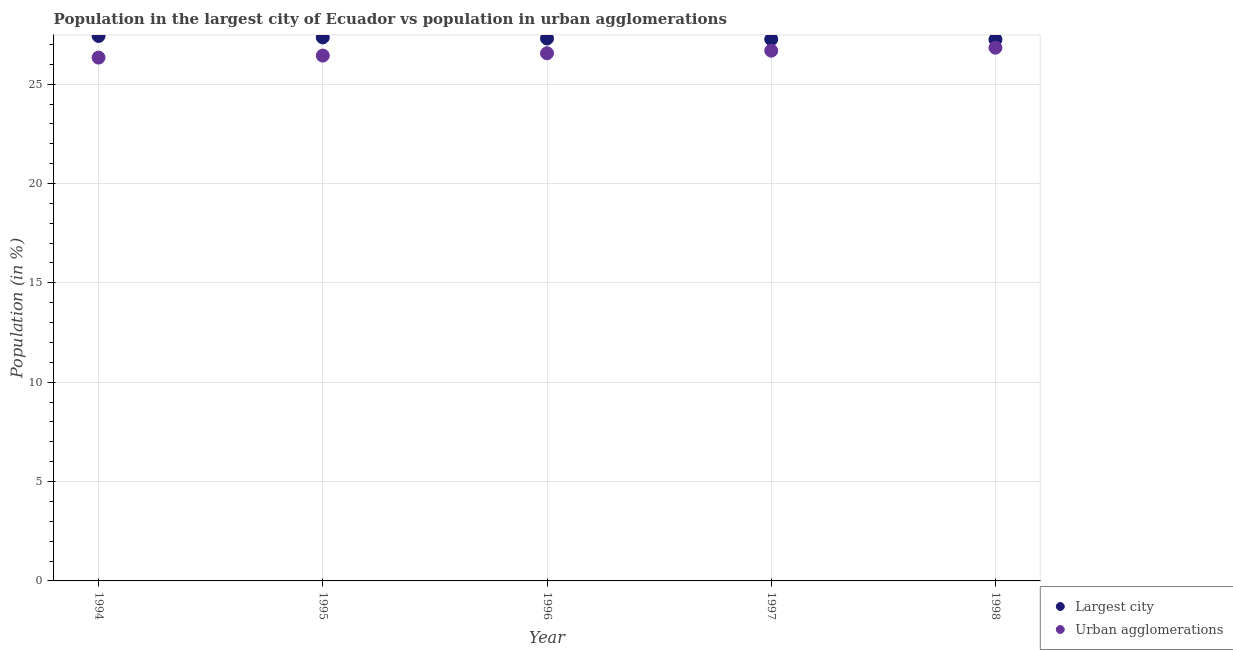What is the population in urban agglomerations in 1996?
Ensure brevity in your answer.  26.56. Across all years, what is the maximum population in the largest city?
Your response must be concise. 27.43. Across all years, what is the minimum population in urban agglomerations?
Your answer should be very brief. 26.34. In which year was the population in the largest city minimum?
Ensure brevity in your answer.  1998. What is the total population in the largest city in the graph?
Your answer should be compact. 136.58. What is the difference between the population in urban agglomerations in 1994 and that in 1997?
Keep it short and to the point. -0.35. What is the difference between the population in the largest city in 1997 and the population in urban agglomerations in 1994?
Ensure brevity in your answer.  0.92. What is the average population in urban agglomerations per year?
Give a very brief answer. 26.57. In the year 1998, what is the difference between the population in urban agglomerations and population in the largest city?
Ensure brevity in your answer.  -0.41. What is the ratio of the population in urban agglomerations in 1995 to that in 1997?
Offer a terse response. 0.99. What is the difference between the highest and the second highest population in urban agglomerations?
Offer a very short reply. 0.15. What is the difference between the highest and the lowest population in urban agglomerations?
Give a very brief answer. 0.5. Is the sum of the population in the largest city in 1994 and 1997 greater than the maximum population in urban agglomerations across all years?
Provide a short and direct response. Yes. Is the population in urban agglomerations strictly greater than the population in the largest city over the years?
Provide a short and direct response. No. How many years are there in the graph?
Your answer should be very brief. 5. Are the values on the major ticks of Y-axis written in scientific E-notation?
Offer a very short reply. No. Does the graph contain grids?
Keep it short and to the point. Yes. How are the legend labels stacked?
Your answer should be very brief. Vertical. What is the title of the graph?
Your answer should be compact. Population in the largest city of Ecuador vs population in urban agglomerations. Does "Technicians" appear as one of the legend labels in the graph?
Your response must be concise. No. What is the label or title of the X-axis?
Keep it short and to the point. Year. What is the label or title of the Y-axis?
Keep it short and to the point. Population (in %). What is the Population (in %) of Largest city in 1994?
Keep it short and to the point. 27.43. What is the Population (in %) of Urban agglomerations in 1994?
Ensure brevity in your answer.  26.34. What is the Population (in %) in Largest city in 1995?
Ensure brevity in your answer.  27.35. What is the Population (in %) of Urban agglomerations in 1995?
Offer a terse response. 26.44. What is the Population (in %) of Largest city in 1996?
Ensure brevity in your answer.  27.3. What is the Population (in %) of Urban agglomerations in 1996?
Your answer should be very brief. 26.56. What is the Population (in %) of Largest city in 1997?
Ensure brevity in your answer.  27.26. What is the Population (in %) of Urban agglomerations in 1997?
Your response must be concise. 26.69. What is the Population (in %) of Largest city in 1998?
Your response must be concise. 27.25. What is the Population (in %) in Urban agglomerations in 1998?
Ensure brevity in your answer.  26.84. Across all years, what is the maximum Population (in %) of Largest city?
Provide a short and direct response. 27.43. Across all years, what is the maximum Population (in %) of Urban agglomerations?
Give a very brief answer. 26.84. Across all years, what is the minimum Population (in %) of Largest city?
Offer a very short reply. 27.25. Across all years, what is the minimum Population (in %) of Urban agglomerations?
Provide a succinct answer. 26.34. What is the total Population (in %) in Largest city in the graph?
Ensure brevity in your answer.  136.58. What is the total Population (in %) of Urban agglomerations in the graph?
Give a very brief answer. 132.85. What is the difference between the Population (in %) in Largest city in 1994 and that in 1995?
Offer a very short reply. 0.07. What is the difference between the Population (in %) of Urban agglomerations in 1994 and that in 1995?
Your answer should be very brief. -0.1. What is the difference between the Population (in %) of Largest city in 1994 and that in 1996?
Make the answer very short. 0.13. What is the difference between the Population (in %) in Urban agglomerations in 1994 and that in 1996?
Your answer should be compact. -0.22. What is the difference between the Population (in %) of Largest city in 1994 and that in 1997?
Give a very brief answer. 0.16. What is the difference between the Population (in %) in Urban agglomerations in 1994 and that in 1997?
Your answer should be very brief. -0.35. What is the difference between the Population (in %) in Largest city in 1994 and that in 1998?
Ensure brevity in your answer.  0.18. What is the difference between the Population (in %) of Urban agglomerations in 1994 and that in 1998?
Your response must be concise. -0.5. What is the difference between the Population (in %) of Largest city in 1995 and that in 1996?
Make the answer very short. 0.05. What is the difference between the Population (in %) in Urban agglomerations in 1995 and that in 1996?
Offer a very short reply. -0.12. What is the difference between the Population (in %) of Largest city in 1995 and that in 1997?
Ensure brevity in your answer.  0.09. What is the difference between the Population (in %) of Urban agglomerations in 1995 and that in 1997?
Make the answer very short. -0.25. What is the difference between the Population (in %) of Largest city in 1995 and that in 1998?
Provide a short and direct response. 0.11. What is the difference between the Population (in %) in Urban agglomerations in 1995 and that in 1998?
Offer a terse response. -0.4. What is the difference between the Population (in %) of Largest city in 1996 and that in 1997?
Your answer should be very brief. 0.04. What is the difference between the Population (in %) in Urban agglomerations in 1996 and that in 1997?
Offer a terse response. -0.13. What is the difference between the Population (in %) of Largest city in 1996 and that in 1998?
Offer a very short reply. 0.05. What is the difference between the Population (in %) of Urban agglomerations in 1996 and that in 1998?
Your answer should be compact. -0.28. What is the difference between the Population (in %) of Largest city in 1997 and that in 1998?
Make the answer very short. 0.02. What is the difference between the Population (in %) in Urban agglomerations in 1997 and that in 1998?
Your answer should be very brief. -0.15. What is the difference between the Population (in %) in Largest city in 1994 and the Population (in %) in Urban agglomerations in 1995?
Your answer should be very brief. 0.99. What is the difference between the Population (in %) of Largest city in 1994 and the Population (in %) of Urban agglomerations in 1996?
Provide a short and direct response. 0.87. What is the difference between the Population (in %) in Largest city in 1994 and the Population (in %) in Urban agglomerations in 1997?
Offer a terse response. 0.74. What is the difference between the Population (in %) of Largest city in 1994 and the Population (in %) of Urban agglomerations in 1998?
Offer a terse response. 0.59. What is the difference between the Population (in %) of Largest city in 1995 and the Population (in %) of Urban agglomerations in 1996?
Your answer should be very brief. 0.8. What is the difference between the Population (in %) in Largest city in 1995 and the Population (in %) in Urban agglomerations in 1997?
Keep it short and to the point. 0.67. What is the difference between the Population (in %) of Largest city in 1995 and the Population (in %) of Urban agglomerations in 1998?
Offer a very short reply. 0.52. What is the difference between the Population (in %) of Largest city in 1996 and the Population (in %) of Urban agglomerations in 1997?
Offer a terse response. 0.61. What is the difference between the Population (in %) in Largest city in 1996 and the Population (in %) in Urban agglomerations in 1998?
Your response must be concise. 0.46. What is the difference between the Population (in %) in Largest city in 1997 and the Population (in %) in Urban agglomerations in 1998?
Ensure brevity in your answer.  0.43. What is the average Population (in %) in Largest city per year?
Provide a succinct answer. 27.32. What is the average Population (in %) of Urban agglomerations per year?
Offer a very short reply. 26.57. In the year 1994, what is the difference between the Population (in %) of Largest city and Population (in %) of Urban agglomerations?
Provide a short and direct response. 1.09. In the year 1995, what is the difference between the Population (in %) of Largest city and Population (in %) of Urban agglomerations?
Offer a very short reply. 0.92. In the year 1996, what is the difference between the Population (in %) in Largest city and Population (in %) in Urban agglomerations?
Your answer should be compact. 0.74. In the year 1997, what is the difference between the Population (in %) of Largest city and Population (in %) of Urban agglomerations?
Ensure brevity in your answer.  0.58. In the year 1998, what is the difference between the Population (in %) in Largest city and Population (in %) in Urban agglomerations?
Keep it short and to the point. 0.41. What is the ratio of the Population (in %) in Urban agglomerations in 1994 to that in 1995?
Ensure brevity in your answer.  1. What is the ratio of the Population (in %) of Urban agglomerations in 1994 to that in 1996?
Provide a short and direct response. 0.99. What is the ratio of the Population (in %) of Largest city in 1994 to that in 1997?
Your response must be concise. 1.01. What is the ratio of the Population (in %) in Urban agglomerations in 1994 to that in 1997?
Provide a succinct answer. 0.99. What is the ratio of the Population (in %) in Largest city in 1994 to that in 1998?
Your response must be concise. 1.01. What is the ratio of the Population (in %) of Urban agglomerations in 1994 to that in 1998?
Provide a short and direct response. 0.98. What is the ratio of the Population (in %) of Largest city in 1995 to that in 1996?
Give a very brief answer. 1. What is the ratio of the Population (in %) of Largest city in 1995 to that in 1998?
Offer a very short reply. 1. What is the ratio of the Population (in %) in Urban agglomerations in 1995 to that in 1998?
Make the answer very short. 0.99. What is the ratio of the Population (in %) in Urban agglomerations in 1996 to that in 1997?
Your answer should be very brief. 1. What is the ratio of the Population (in %) in Largest city in 1997 to that in 1998?
Provide a succinct answer. 1. What is the ratio of the Population (in %) of Urban agglomerations in 1997 to that in 1998?
Provide a succinct answer. 0.99. What is the difference between the highest and the second highest Population (in %) in Largest city?
Make the answer very short. 0.07. What is the difference between the highest and the second highest Population (in %) in Urban agglomerations?
Keep it short and to the point. 0.15. What is the difference between the highest and the lowest Population (in %) in Largest city?
Offer a very short reply. 0.18. What is the difference between the highest and the lowest Population (in %) in Urban agglomerations?
Offer a very short reply. 0.5. 